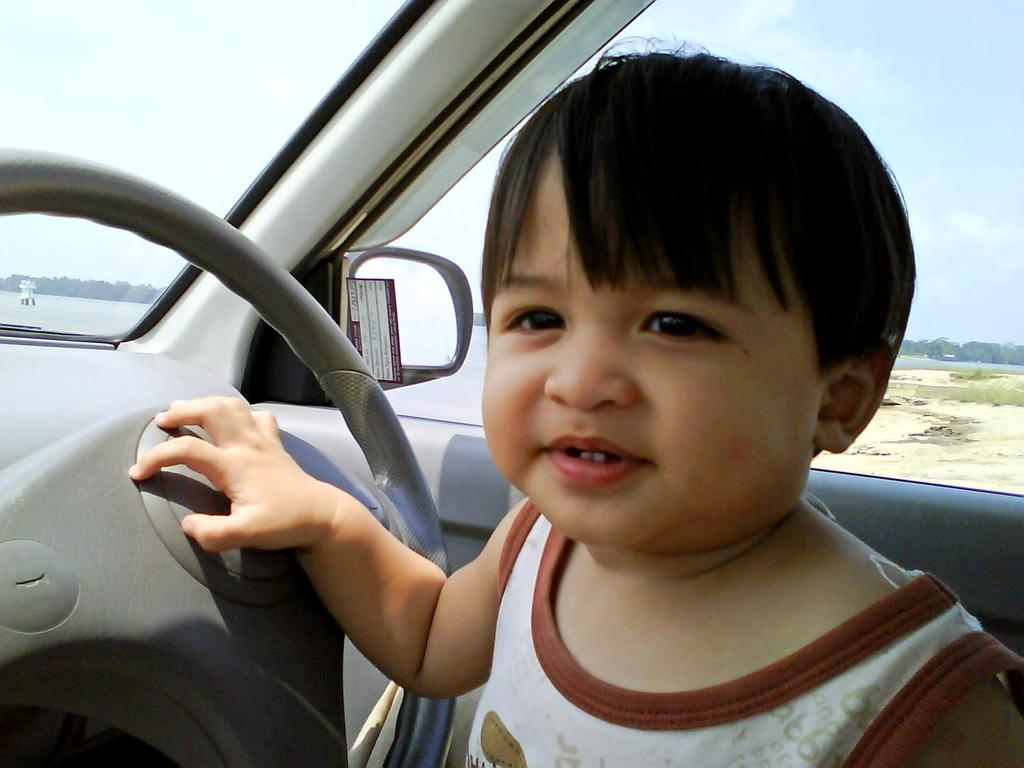What is the main subject of the image? The main subject of the image is a kid. What is the kid holding in the image? The kid is holding a steering wheel. What might be the kid's location in the image? It appears that the kid is sitting in a car. What can be seen in the background of the image? There is a cloudy sky in the background of the image. How many rabbits can be seen playing near the mailbox in the image? There are no rabbits or mailboxes present in the image. 